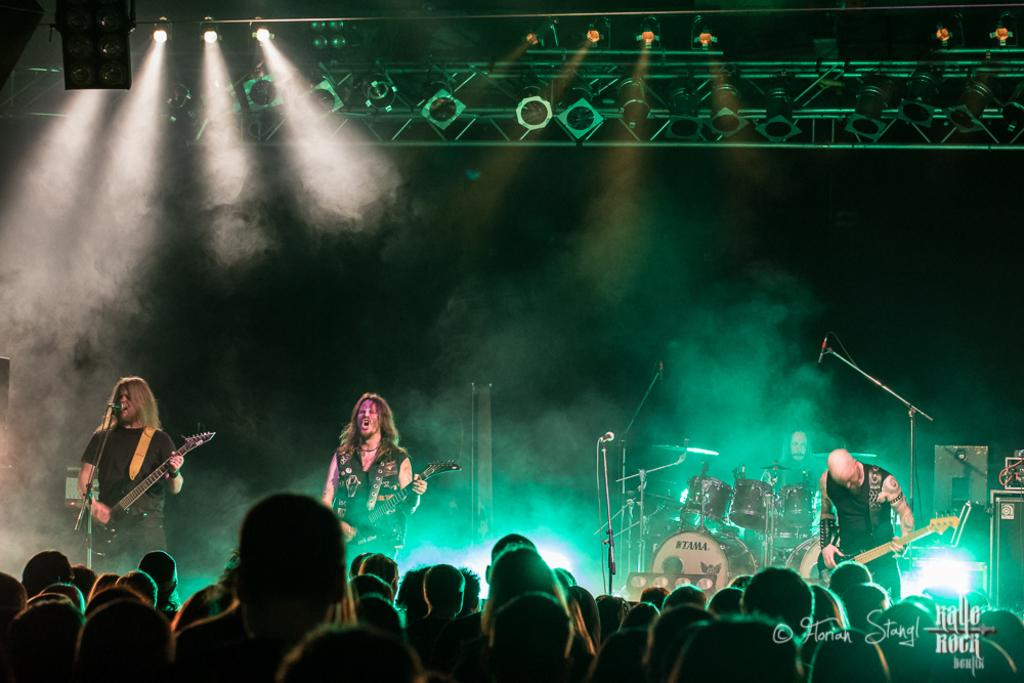What is happening in the image involving a group of people? The people in the image are standing on a stage and playing musical instruments. What can be seen in the background of the image? There are lights and rods visible in the background of the image. What type of locket is being worn by the person playing the guitar in the image? There is no locket visible on any person in the image, as the focus is on the group of people playing musical instruments on a stage. 